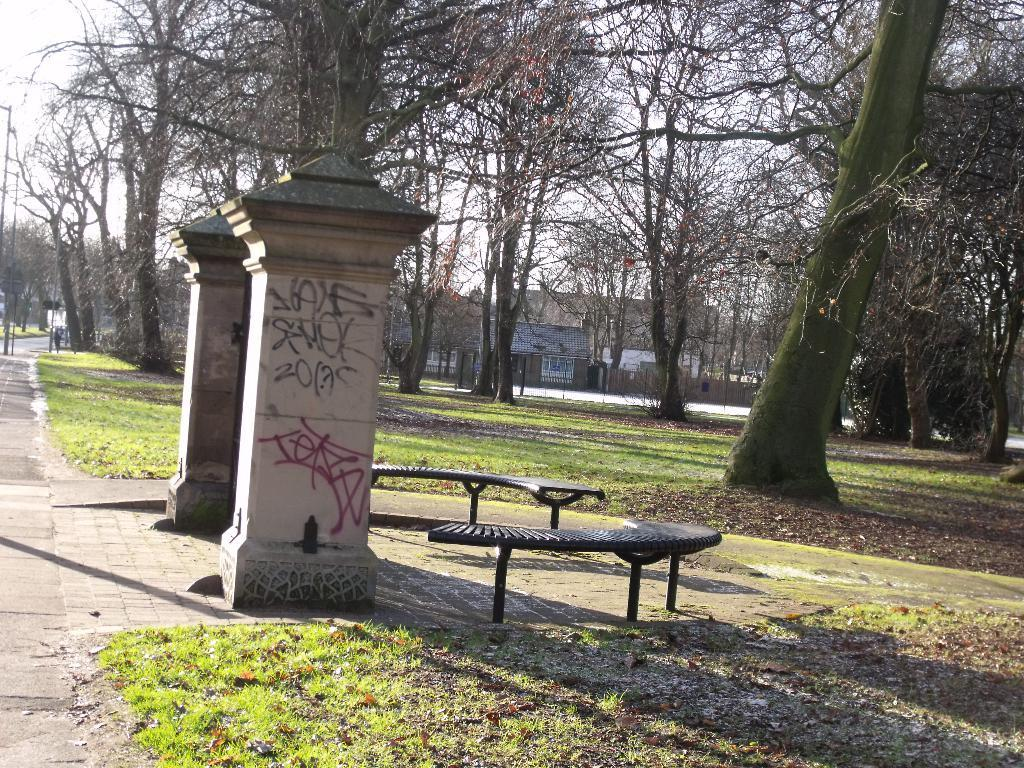What type of vegetation can be seen in the image? There are trees in the image. What type of structures are present in the image? There are buildings in the image. What type of ground cover is visible in the image? There is grass in the image. What type of seating can be seen in the image? There are benches in the image. What is visible in the background of the image? The sky is visible in the image. How many girls are playing with the son in the image? There are no girls or son present in the image. What type of memory is being captured in the image? The image does not depict a specific memory; it shows trees, buildings, grass, benches, and the sky. 